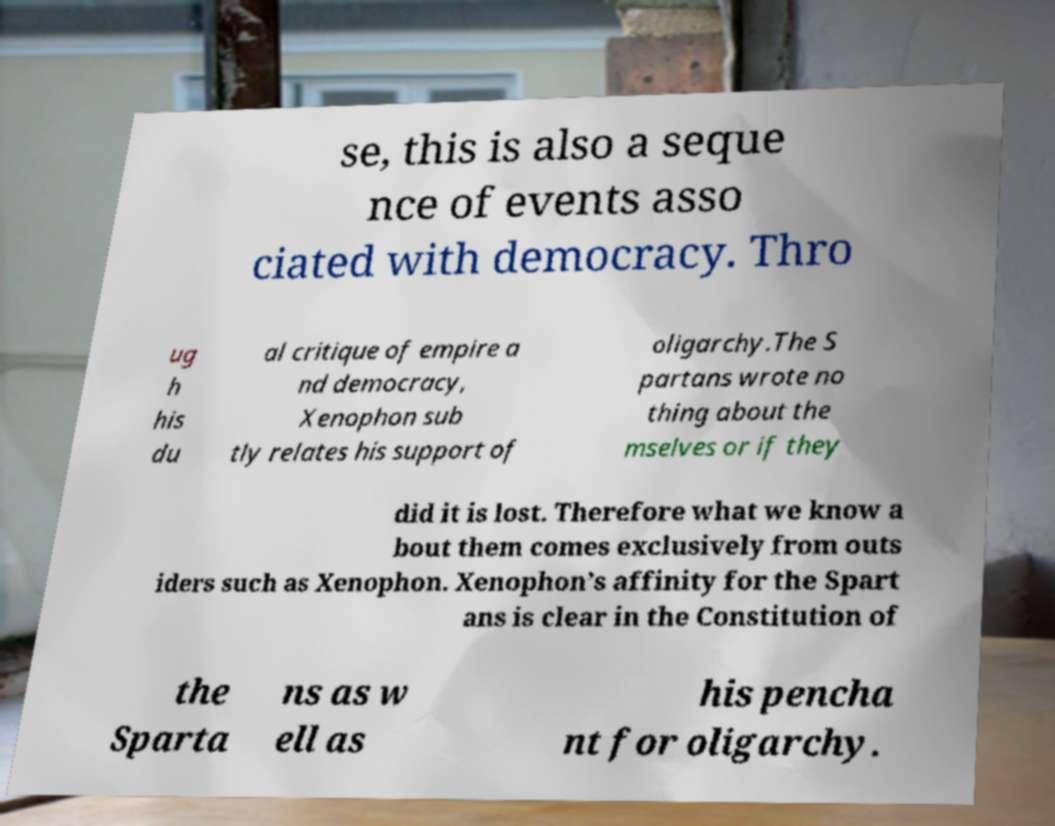There's text embedded in this image that I need extracted. Can you transcribe it verbatim? se, this is also a seque nce of events asso ciated with democracy. Thro ug h his du al critique of empire a nd democracy, Xenophon sub tly relates his support of oligarchy.The S partans wrote no thing about the mselves or if they did it is lost. Therefore what we know a bout them comes exclusively from outs iders such as Xenophon. Xenophon’s affinity for the Spart ans is clear in the Constitution of the Sparta ns as w ell as his pencha nt for oligarchy. 